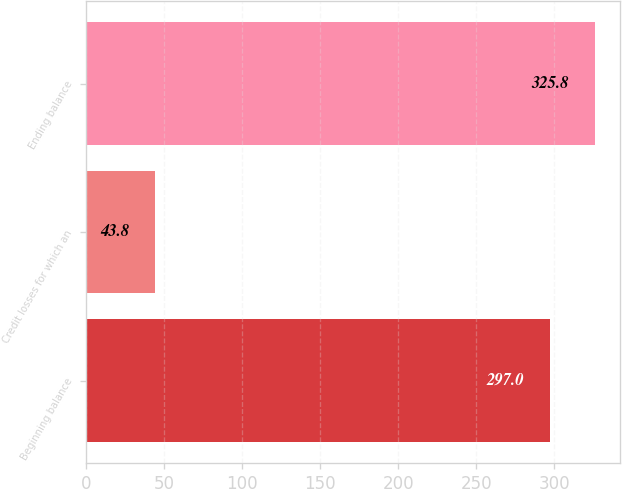<chart> <loc_0><loc_0><loc_500><loc_500><bar_chart><fcel>Beginning balance<fcel>Credit losses for which an<fcel>Ending balance<nl><fcel>297<fcel>43.8<fcel>325.8<nl></chart> 